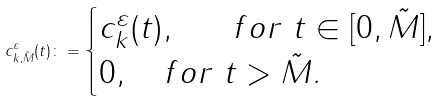Convert formula to latex. <formula><loc_0><loc_0><loc_500><loc_500>c _ { k , \tilde { M } } ^ { \varepsilon } ( t ) \colon = \begin{cases} c ^ { \varepsilon } _ { k } ( t ) , \quad \ \ f o r \ t \in [ 0 , \tilde { M } ] , \\ 0 , \quad f o r \ t > \tilde { M } . \end{cases}</formula> 